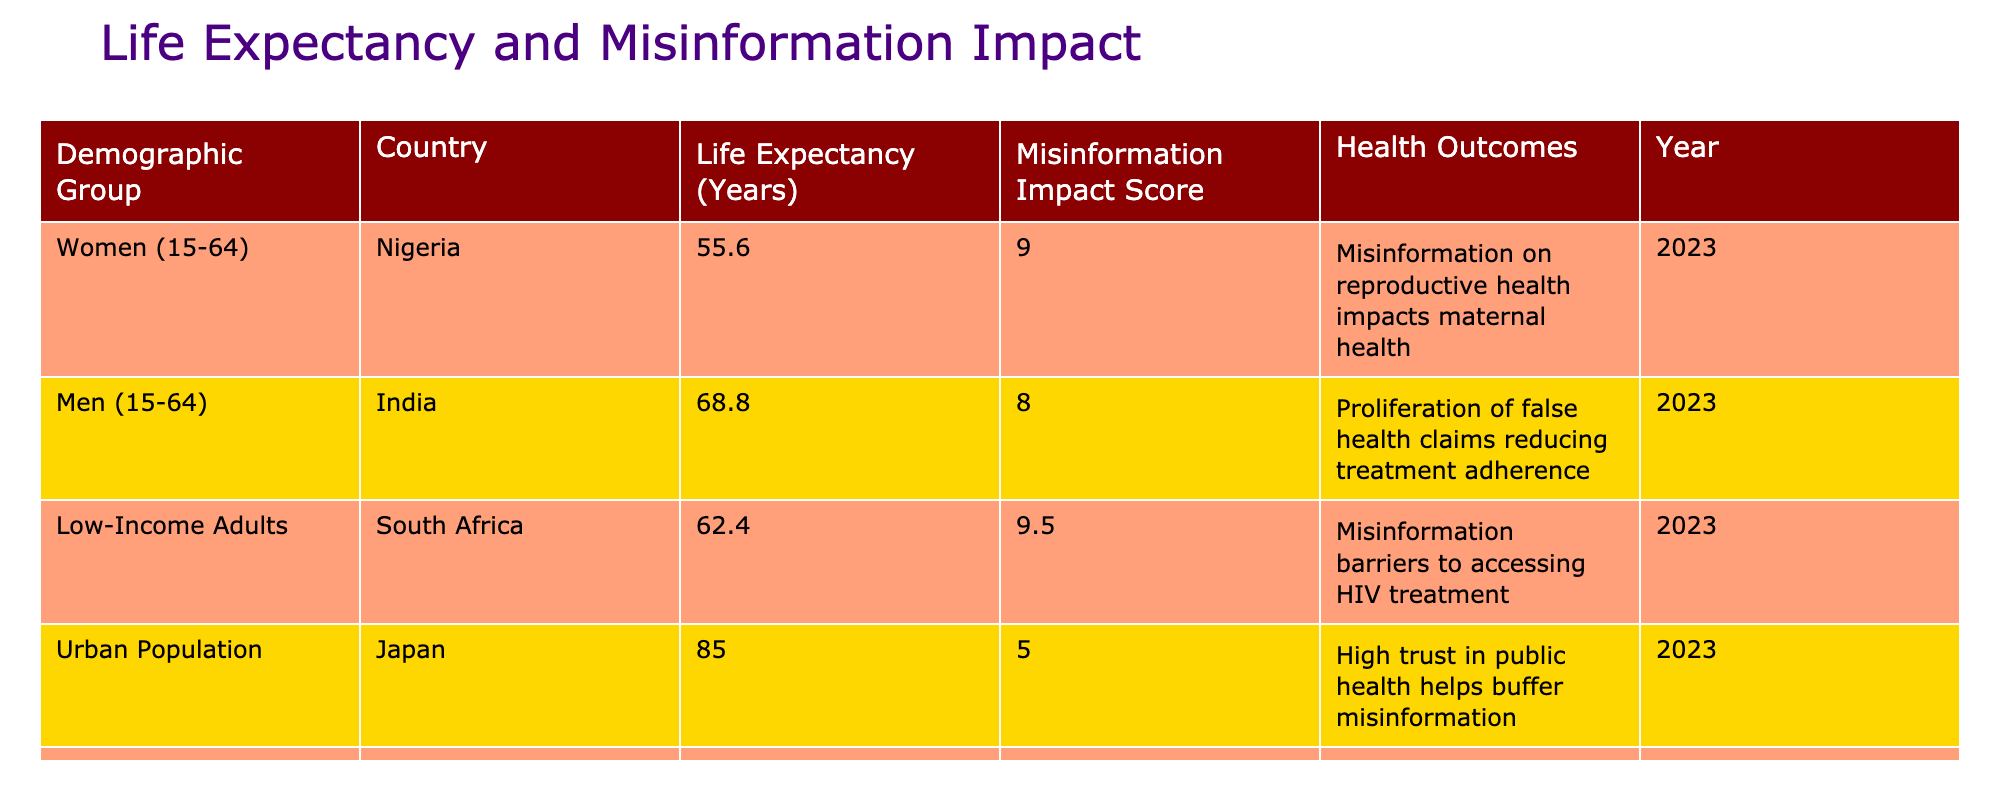What is the life expectancy of women aged 15-64 in Nigeria? The table shows that the life expectancy for women aged 15-64 in Nigeria is listed directly under the corresponding row. The value is 55.6 years.
Answer: 55.6 Which demographic group has the highest misinformation impact score? Looking at the misinformation impact scores listed in the table, Low-Income Adults in South Africa have the highest score of 9.5, which is greater than any other group.
Answer: 9.5 What is the average life expectancy of the urban population in Japan and the rural population in Indonesia? The life expectancy for the urban population in Japan is 85.0 years, and for the rural population in Indonesia, it is 70.2 years. To find the average, sum these two values: (85.0 + 70.2) = 155.2. Then divide by 2, so 155.2 / 2 = 77.6 years.
Answer: 77.6 Is the misinformation impact score for men aged 15-64 in India greater than that of women aged 15-64 in Nigeria? The misinformation impact score for men in India is 8.0, while the score for women in Nigeria is 9.0. Therefore, 8.0 is less than 9.0, making the statement false.
Answer: No How does the misinformation impact score relate to life expectancy in the demographic groups presented? Analyzing the data, we see a negative correlation: as the misinformation impact score increases, the life expectancy tends to decrease, especially in the cases of Nigeria and South Africa with lower life expectancy and higher scores. Conversely, Japan's urban population has a high life expectancy and a lower misinformation score, supporting the idea that misinformation negatively impacts public health outcomes.
Answer: Misinformation negatively impacts life expectancy 